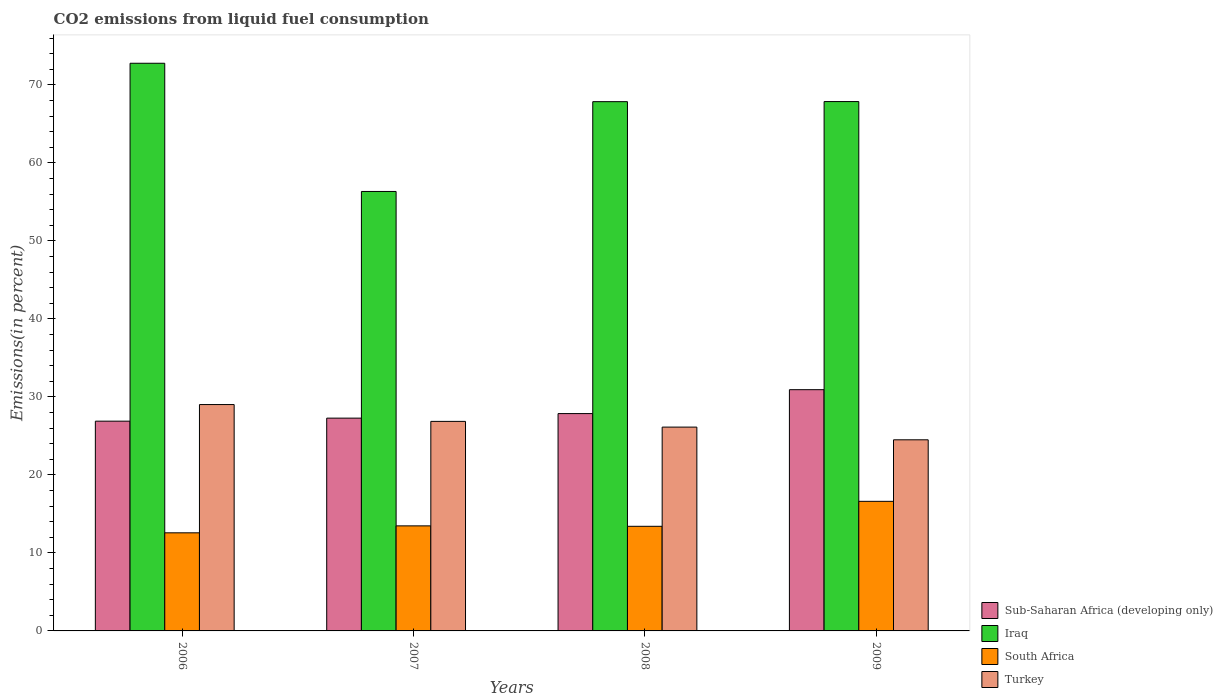How many groups of bars are there?
Your answer should be compact. 4. Are the number of bars on each tick of the X-axis equal?
Your response must be concise. Yes. How many bars are there on the 2nd tick from the right?
Your response must be concise. 4. What is the total CO2 emitted in Iraq in 2007?
Offer a very short reply. 56.34. Across all years, what is the maximum total CO2 emitted in Sub-Saharan Africa (developing only)?
Give a very brief answer. 30.93. Across all years, what is the minimum total CO2 emitted in Sub-Saharan Africa (developing only)?
Provide a short and direct response. 26.89. In which year was the total CO2 emitted in Iraq maximum?
Make the answer very short. 2006. What is the total total CO2 emitted in Sub-Saharan Africa (developing only) in the graph?
Offer a terse response. 112.95. What is the difference between the total CO2 emitted in Turkey in 2007 and that in 2009?
Provide a short and direct response. 2.36. What is the difference between the total CO2 emitted in Turkey in 2007 and the total CO2 emitted in Iraq in 2008?
Your answer should be very brief. -40.99. What is the average total CO2 emitted in South Africa per year?
Keep it short and to the point. 14.02. In the year 2009, what is the difference between the total CO2 emitted in Turkey and total CO2 emitted in South Africa?
Your answer should be very brief. 7.89. What is the ratio of the total CO2 emitted in South Africa in 2006 to that in 2007?
Your answer should be compact. 0.93. What is the difference between the highest and the second highest total CO2 emitted in Sub-Saharan Africa (developing only)?
Offer a terse response. 3.06. What is the difference between the highest and the lowest total CO2 emitted in Iraq?
Give a very brief answer. 16.44. In how many years, is the total CO2 emitted in Turkey greater than the average total CO2 emitted in Turkey taken over all years?
Your answer should be compact. 2. Is the sum of the total CO2 emitted in South Africa in 2008 and 2009 greater than the maximum total CO2 emitted in Turkey across all years?
Your answer should be very brief. Yes. What does the 2nd bar from the left in 2007 represents?
Give a very brief answer. Iraq. What does the 2nd bar from the right in 2006 represents?
Keep it short and to the point. South Africa. Are the values on the major ticks of Y-axis written in scientific E-notation?
Your answer should be compact. No. Does the graph contain any zero values?
Offer a terse response. No. Does the graph contain grids?
Your answer should be compact. No. Where does the legend appear in the graph?
Your answer should be compact. Bottom right. How many legend labels are there?
Your answer should be compact. 4. How are the legend labels stacked?
Your answer should be very brief. Vertical. What is the title of the graph?
Keep it short and to the point. CO2 emissions from liquid fuel consumption. Does "Gabon" appear as one of the legend labels in the graph?
Your answer should be very brief. No. What is the label or title of the X-axis?
Ensure brevity in your answer.  Years. What is the label or title of the Y-axis?
Your response must be concise. Emissions(in percent). What is the Emissions(in percent) of Sub-Saharan Africa (developing only) in 2006?
Your response must be concise. 26.89. What is the Emissions(in percent) in Iraq in 2006?
Your answer should be very brief. 72.77. What is the Emissions(in percent) in South Africa in 2006?
Offer a terse response. 12.58. What is the Emissions(in percent) in Turkey in 2006?
Ensure brevity in your answer.  29.02. What is the Emissions(in percent) of Sub-Saharan Africa (developing only) in 2007?
Provide a succinct answer. 27.28. What is the Emissions(in percent) of Iraq in 2007?
Your response must be concise. 56.34. What is the Emissions(in percent) in South Africa in 2007?
Your response must be concise. 13.47. What is the Emissions(in percent) of Turkey in 2007?
Give a very brief answer. 26.86. What is the Emissions(in percent) in Sub-Saharan Africa (developing only) in 2008?
Provide a succinct answer. 27.86. What is the Emissions(in percent) of Iraq in 2008?
Your answer should be very brief. 67.85. What is the Emissions(in percent) of South Africa in 2008?
Keep it short and to the point. 13.41. What is the Emissions(in percent) in Turkey in 2008?
Your answer should be very brief. 26.13. What is the Emissions(in percent) in Sub-Saharan Africa (developing only) in 2009?
Ensure brevity in your answer.  30.93. What is the Emissions(in percent) in Iraq in 2009?
Provide a short and direct response. 67.86. What is the Emissions(in percent) of South Africa in 2009?
Offer a very short reply. 16.61. What is the Emissions(in percent) in Turkey in 2009?
Provide a succinct answer. 24.5. Across all years, what is the maximum Emissions(in percent) in Sub-Saharan Africa (developing only)?
Make the answer very short. 30.93. Across all years, what is the maximum Emissions(in percent) of Iraq?
Provide a short and direct response. 72.77. Across all years, what is the maximum Emissions(in percent) in South Africa?
Keep it short and to the point. 16.61. Across all years, what is the maximum Emissions(in percent) in Turkey?
Your answer should be very brief. 29.02. Across all years, what is the minimum Emissions(in percent) of Sub-Saharan Africa (developing only)?
Ensure brevity in your answer.  26.89. Across all years, what is the minimum Emissions(in percent) of Iraq?
Provide a short and direct response. 56.34. Across all years, what is the minimum Emissions(in percent) of South Africa?
Provide a succinct answer. 12.58. Across all years, what is the minimum Emissions(in percent) in Turkey?
Your answer should be compact. 24.5. What is the total Emissions(in percent) of Sub-Saharan Africa (developing only) in the graph?
Your answer should be very brief. 112.95. What is the total Emissions(in percent) in Iraq in the graph?
Make the answer very short. 264.82. What is the total Emissions(in percent) in South Africa in the graph?
Your answer should be very brief. 56.07. What is the total Emissions(in percent) of Turkey in the graph?
Your response must be concise. 106.51. What is the difference between the Emissions(in percent) of Sub-Saharan Africa (developing only) in 2006 and that in 2007?
Offer a terse response. -0.39. What is the difference between the Emissions(in percent) in Iraq in 2006 and that in 2007?
Provide a succinct answer. 16.44. What is the difference between the Emissions(in percent) of South Africa in 2006 and that in 2007?
Provide a succinct answer. -0.89. What is the difference between the Emissions(in percent) in Turkey in 2006 and that in 2007?
Make the answer very short. 2.16. What is the difference between the Emissions(in percent) of Sub-Saharan Africa (developing only) in 2006 and that in 2008?
Make the answer very short. -0.97. What is the difference between the Emissions(in percent) in Iraq in 2006 and that in 2008?
Give a very brief answer. 4.92. What is the difference between the Emissions(in percent) of South Africa in 2006 and that in 2008?
Ensure brevity in your answer.  -0.83. What is the difference between the Emissions(in percent) of Turkey in 2006 and that in 2008?
Offer a terse response. 2.89. What is the difference between the Emissions(in percent) in Sub-Saharan Africa (developing only) in 2006 and that in 2009?
Offer a very short reply. -4.03. What is the difference between the Emissions(in percent) of Iraq in 2006 and that in 2009?
Make the answer very short. 4.91. What is the difference between the Emissions(in percent) in South Africa in 2006 and that in 2009?
Keep it short and to the point. -4.03. What is the difference between the Emissions(in percent) in Turkey in 2006 and that in 2009?
Your answer should be compact. 4.52. What is the difference between the Emissions(in percent) of Sub-Saharan Africa (developing only) in 2007 and that in 2008?
Give a very brief answer. -0.58. What is the difference between the Emissions(in percent) of Iraq in 2007 and that in 2008?
Your response must be concise. -11.51. What is the difference between the Emissions(in percent) of South Africa in 2007 and that in 2008?
Offer a very short reply. 0.05. What is the difference between the Emissions(in percent) of Turkey in 2007 and that in 2008?
Make the answer very short. 0.73. What is the difference between the Emissions(in percent) in Sub-Saharan Africa (developing only) in 2007 and that in 2009?
Provide a short and direct response. -3.65. What is the difference between the Emissions(in percent) in Iraq in 2007 and that in 2009?
Your response must be concise. -11.52. What is the difference between the Emissions(in percent) in South Africa in 2007 and that in 2009?
Offer a terse response. -3.15. What is the difference between the Emissions(in percent) in Turkey in 2007 and that in 2009?
Provide a short and direct response. 2.36. What is the difference between the Emissions(in percent) in Sub-Saharan Africa (developing only) in 2008 and that in 2009?
Give a very brief answer. -3.06. What is the difference between the Emissions(in percent) in Iraq in 2008 and that in 2009?
Make the answer very short. -0.01. What is the difference between the Emissions(in percent) of South Africa in 2008 and that in 2009?
Ensure brevity in your answer.  -3.2. What is the difference between the Emissions(in percent) of Turkey in 2008 and that in 2009?
Your response must be concise. 1.63. What is the difference between the Emissions(in percent) of Sub-Saharan Africa (developing only) in 2006 and the Emissions(in percent) of Iraq in 2007?
Offer a very short reply. -29.45. What is the difference between the Emissions(in percent) in Sub-Saharan Africa (developing only) in 2006 and the Emissions(in percent) in South Africa in 2007?
Provide a short and direct response. 13.42. What is the difference between the Emissions(in percent) in Sub-Saharan Africa (developing only) in 2006 and the Emissions(in percent) in Turkey in 2007?
Offer a very short reply. 0.03. What is the difference between the Emissions(in percent) of Iraq in 2006 and the Emissions(in percent) of South Africa in 2007?
Give a very brief answer. 59.3. What is the difference between the Emissions(in percent) in Iraq in 2006 and the Emissions(in percent) in Turkey in 2007?
Give a very brief answer. 45.91. What is the difference between the Emissions(in percent) of South Africa in 2006 and the Emissions(in percent) of Turkey in 2007?
Give a very brief answer. -14.28. What is the difference between the Emissions(in percent) of Sub-Saharan Africa (developing only) in 2006 and the Emissions(in percent) of Iraq in 2008?
Provide a succinct answer. -40.96. What is the difference between the Emissions(in percent) in Sub-Saharan Africa (developing only) in 2006 and the Emissions(in percent) in South Africa in 2008?
Ensure brevity in your answer.  13.48. What is the difference between the Emissions(in percent) of Sub-Saharan Africa (developing only) in 2006 and the Emissions(in percent) of Turkey in 2008?
Ensure brevity in your answer.  0.76. What is the difference between the Emissions(in percent) in Iraq in 2006 and the Emissions(in percent) in South Africa in 2008?
Your answer should be compact. 59.36. What is the difference between the Emissions(in percent) in Iraq in 2006 and the Emissions(in percent) in Turkey in 2008?
Make the answer very short. 46.64. What is the difference between the Emissions(in percent) of South Africa in 2006 and the Emissions(in percent) of Turkey in 2008?
Give a very brief answer. -13.55. What is the difference between the Emissions(in percent) in Sub-Saharan Africa (developing only) in 2006 and the Emissions(in percent) in Iraq in 2009?
Offer a terse response. -40.97. What is the difference between the Emissions(in percent) in Sub-Saharan Africa (developing only) in 2006 and the Emissions(in percent) in South Africa in 2009?
Your response must be concise. 10.28. What is the difference between the Emissions(in percent) of Sub-Saharan Africa (developing only) in 2006 and the Emissions(in percent) of Turkey in 2009?
Keep it short and to the point. 2.39. What is the difference between the Emissions(in percent) in Iraq in 2006 and the Emissions(in percent) in South Africa in 2009?
Offer a very short reply. 56.16. What is the difference between the Emissions(in percent) in Iraq in 2006 and the Emissions(in percent) in Turkey in 2009?
Make the answer very short. 48.27. What is the difference between the Emissions(in percent) in South Africa in 2006 and the Emissions(in percent) in Turkey in 2009?
Provide a succinct answer. -11.92. What is the difference between the Emissions(in percent) in Sub-Saharan Africa (developing only) in 2007 and the Emissions(in percent) in Iraq in 2008?
Make the answer very short. -40.57. What is the difference between the Emissions(in percent) in Sub-Saharan Africa (developing only) in 2007 and the Emissions(in percent) in South Africa in 2008?
Offer a terse response. 13.87. What is the difference between the Emissions(in percent) of Sub-Saharan Africa (developing only) in 2007 and the Emissions(in percent) of Turkey in 2008?
Provide a short and direct response. 1.15. What is the difference between the Emissions(in percent) in Iraq in 2007 and the Emissions(in percent) in South Africa in 2008?
Your answer should be very brief. 42.92. What is the difference between the Emissions(in percent) in Iraq in 2007 and the Emissions(in percent) in Turkey in 2008?
Ensure brevity in your answer.  30.21. What is the difference between the Emissions(in percent) in South Africa in 2007 and the Emissions(in percent) in Turkey in 2008?
Your answer should be very brief. -12.66. What is the difference between the Emissions(in percent) in Sub-Saharan Africa (developing only) in 2007 and the Emissions(in percent) in Iraq in 2009?
Your answer should be compact. -40.58. What is the difference between the Emissions(in percent) in Sub-Saharan Africa (developing only) in 2007 and the Emissions(in percent) in South Africa in 2009?
Your answer should be compact. 10.67. What is the difference between the Emissions(in percent) in Sub-Saharan Africa (developing only) in 2007 and the Emissions(in percent) in Turkey in 2009?
Ensure brevity in your answer.  2.78. What is the difference between the Emissions(in percent) in Iraq in 2007 and the Emissions(in percent) in South Africa in 2009?
Your response must be concise. 39.72. What is the difference between the Emissions(in percent) in Iraq in 2007 and the Emissions(in percent) in Turkey in 2009?
Make the answer very short. 31.84. What is the difference between the Emissions(in percent) of South Africa in 2007 and the Emissions(in percent) of Turkey in 2009?
Your response must be concise. -11.03. What is the difference between the Emissions(in percent) of Sub-Saharan Africa (developing only) in 2008 and the Emissions(in percent) of Iraq in 2009?
Ensure brevity in your answer.  -40. What is the difference between the Emissions(in percent) in Sub-Saharan Africa (developing only) in 2008 and the Emissions(in percent) in South Africa in 2009?
Make the answer very short. 11.25. What is the difference between the Emissions(in percent) in Sub-Saharan Africa (developing only) in 2008 and the Emissions(in percent) in Turkey in 2009?
Keep it short and to the point. 3.36. What is the difference between the Emissions(in percent) in Iraq in 2008 and the Emissions(in percent) in South Africa in 2009?
Offer a terse response. 51.24. What is the difference between the Emissions(in percent) of Iraq in 2008 and the Emissions(in percent) of Turkey in 2009?
Keep it short and to the point. 43.35. What is the difference between the Emissions(in percent) of South Africa in 2008 and the Emissions(in percent) of Turkey in 2009?
Offer a terse response. -11.09. What is the average Emissions(in percent) of Sub-Saharan Africa (developing only) per year?
Offer a very short reply. 28.24. What is the average Emissions(in percent) in Iraq per year?
Offer a terse response. 66.2. What is the average Emissions(in percent) in South Africa per year?
Your answer should be compact. 14.02. What is the average Emissions(in percent) of Turkey per year?
Ensure brevity in your answer.  26.63. In the year 2006, what is the difference between the Emissions(in percent) in Sub-Saharan Africa (developing only) and Emissions(in percent) in Iraq?
Offer a very short reply. -45.88. In the year 2006, what is the difference between the Emissions(in percent) of Sub-Saharan Africa (developing only) and Emissions(in percent) of South Africa?
Give a very brief answer. 14.31. In the year 2006, what is the difference between the Emissions(in percent) in Sub-Saharan Africa (developing only) and Emissions(in percent) in Turkey?
Offer a terse response. -2.13. In the year 2006, what is the difference between the Emissions(in percent) of Iraq and Emissions(in percent) of South Africa?
Give a very brief answer. 60.19. In the year 2006, what is the difference between the Emissions(in percent) of Iraq and Emissions(in percent) of Turkey?
Make the answer very short. 43.75. In the year 2006, what is the difference between the Emissions(in percent) in South Africa and Emissions(in percent) in Turkey?
Offer a very short reply. -16.44. In the year 2007, what is the difference between the Emissions(in percent) in Sub-Saharan Africa (developing only) and Emissions(in percent) in Iraq?
Provide a short and direct response. -29.06. In the year 2007, what is the difference between the Emissions(in percent) in Sub-Saharan Africa (developing only) and Emissions(in percent) in South Africa?
Your answer should be very brief. 13.81. In the year 2007, what is the difference between the Emissions(in percent) of Sub-Saharan Africa (developing only) and Emissions(in percent) of Turkey?
Provide a succinct answer. 0.42. In the year 2007, what is the difference between the Emissions(in percent) of Iraq and Emissions(in percent) of South Africa?
Offer a terse response. 42.87. In the year 2007, what is the difference between the Emissions(in percent) in Iraq and Emissions(in percent) in Turkey?
Keep it short and to the point. 29.47. In the year 2007, what is the difference between the Emissions(in percent) in South Africa and Emissions(in percent) in Turkey?
Make the answer very short. -13.39. In the year 2008, what is the difference between the Emissions(in percent) of Sub-Saharan Africa (developing only) and Emissions(in percent) of Iraq?
Your response must be concise. -39.99. In the year 2008, what is the difference between the Emissions(in percent) in Sub-Saharan Africa (developing only) and Emissions(in percent) in South Africa?
Give a very brief answer. 14.45. In the year 2008, what is the difference between the Emissions(in percent) in Sub-Saharan Africa (developing only) and Emissions(in percent) in Turkey?
Your response must be concise. 1.73. In the year 2008, what is the difference between the Emissions(in percent) in Iraq and Emissions(in percent) in South Africa?
Offer a terse response. 54.44. In the year 2008, what is the difference between the Emissions(in percent) of Iraq and Emissions(in percent) of Turkey?
Ensure brevity in your answer.  41.72. In the year 2008, what is the difference between the Emissions(in percent) of South Africa and Emissions(in percent) of Turkey?
Ensure brevity in your answer.  -12.72. In the year 2009, what is the difference between the Emissions(in percent) of Sub-Saharan Africa (developing only) and Emissions(in percent) of Iraq?
Keep it short and to the point. -36.94. In the year 2009, what is the difference between the Emissions(in percent) in Sub-Saharan Africa (developing only) and Emissions(in percent) in South Africa?
Your answer should be compact. 14.31. In the year 2009, what is the difference between the Emissions(in percent) of Sub-Saharan Africa (developing only) and Emissions(in percent) of Turkey?
Your answer should be very brief. 6.42. In the year 2009, what is the difference between the Emissions(in percent) of Iraq and Emissions(in percent) of South Africa?
Offer a very short reply. 51.25. In the year 2009, what is the difference between the Emissions(in percent) in Iraq and Emissions(in percent) in Turkey?
Your response must be concise. 43.36. In the year 2009, what is the difference between the Emissions(in percent) of South Africa and Emissions(in percent) of Turkey?
Give a very brief answer. -7.89. What is the ratio of the Emissions(in percent) in Sub-Saharan Africa (developing only) in 2006 to that in 2007?
Your response must be concise. 0.99. What is the ratio of the Emissions(in percent) in Iraq in 2006 to that in 2007?
Your response must be concise. 1.29. What is the ratio of the Emissions(in percent) in South Africa in 2006 to that in 2007?
Your response must be concise. 0.93. What is the ratio of the Emissions(in percent) in Turkey in 2006 to that in 2007?
Provide a short and direct response. 1.08. What is the ratio of the Emissions(in percent) in Sub-Saharan Africa (developing only) in 2006 to that in 2008?
Your answer should be very brief. 0.97. What is the ratio of the Emissions(in percent) in Iraq in 2006 to that in 2008?
Provide a short and direct response. 1.07. What is the ratio of the Emissions(in percent) of South Africa in 2006 to that in 2008?
Offer a very short reply. 0.94. What is the ratio of the Emissions(in percent) in Turkey in 2006 to that in 2008?
Your answer should be compact. 1.11. What is the ratio of the Emissions(in percent) in Sub-Saharan Africa (developing only) in 2006 to that in 2009?
Give a very brief answer. 0.87. What is the ratio of the Emissions(in percent) of Iraq in 2006 to that in 2009?
Offer a terse response. 1.07. What is the ratio of the Emissions(in percent) in South Africa in 2006 to that in 2009?
Your response must be concise. 0.76. What is the ratio of the Emissions(in percent) in Turkey in 2006 to that in 2009?
Offer a terse response. 1.18. What is the ratio of the Emissions(in percent) in Sub-Saharan Africa (developing only) in 2007 to that in 2008?
Provide a succinct answer. 0.98. What is the ratio of the Emissions(in percent) of Iraq in 2007 to that in 2008?
Keep it short and to the point. 0.83. What is the ratio of the Emissions(in percent) of South Africa in 2007 to that in 2008?
Your answer should be compact. 1. What is the ratio of the Emissions(in percent) in Turkey in 2007 to that in 2008?
Ensure brevity in your answer.  1.03. What is the ratio of the Emissions(in percent) of Sub-Saharan Africa (developing only) in 2007 to that in 2009?
Give a very brief answer. 0.88. What is the ratio of the Emissions(in percent) of Iraq in 2007 to that in 2009?
Your answer should be very brief. 0.83. What is the ratio of the Emissions(in percent) of South Africa in 2007 to that in 2009?
Ensure brevity in your answer.  0.81. What is the ratio of the Emissions(in percent) of Turkey in 2007 to that in 2009?
Provide a short and direct response. 1.1. What is the ratio of the Emissions(in percent) of Sub-Saharan Africa (developing only) in 2008 to that in 2009?
Offer a very short reply. 0.9. What is the ratio of the Emissions(in percent) in Iraq in 2008 to that in 2009?
Provide a succinct answer. 1. What is the ratio of the Emissions(in percent) in South Africa in 2008 to that in 2009?
Make the answer very short. 0.81. What is the ratio of the Emissions(in percent) in Turkey in 2008 to that in 2009?
Your answer should be very brief. 1.07. What is the difference between the highest and the second highest Emissions(in percent) in Sub-Saharan Africa (developing only)?
Provide a succinct answer. 3.06. What is the difference between the highest and the second highest Emissions(in percent) of Iraq?
Keep it short and to the point. 4.91. What is the difference between the highest and the second highest Emissions(in percent) of South Africa?
Your answer should be compact. 3.15. What is the difference between the highest and the second highest Emissions(in percent) in Turkey?
Your response must be concise. 2.16. What is the difference between the highest and the lowest Emissions(in percent) of Sub-Saharan Africa (developing only)?
Your answer should be very brief. 4.03. What is the difference between the highest and the lowest Emissions(in percent) in Iraq?
Give a very brief answer. 16.44. What is the difference between the highest and the lowest Emissions(in percent) of South Africa?
Ensure brevity in your answer.  4.03. What is the difference between the highest and the lowest Emissions(in percent) of Turkey?
Your response must be concise. 4.52. 